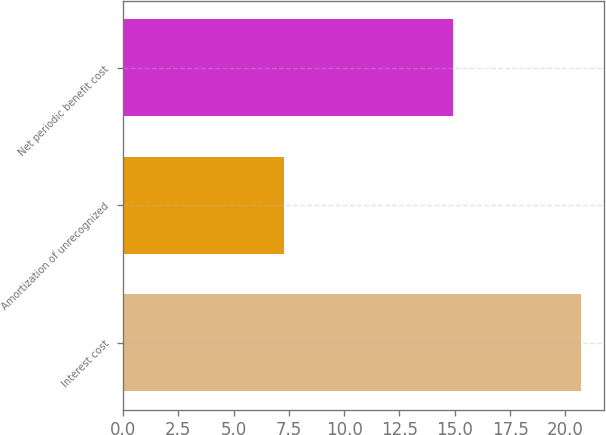Convert chart to OTSL. <chart><loc_0><loc_0><loc_500><loc_500><bar_chart><fcel>Interest cost<fcel>Amortization of unrecognized<fcel>Net periodic benefit cost<nl><fcel>20.7<fcel>7.3<fcel>14.9<nl></chart> 